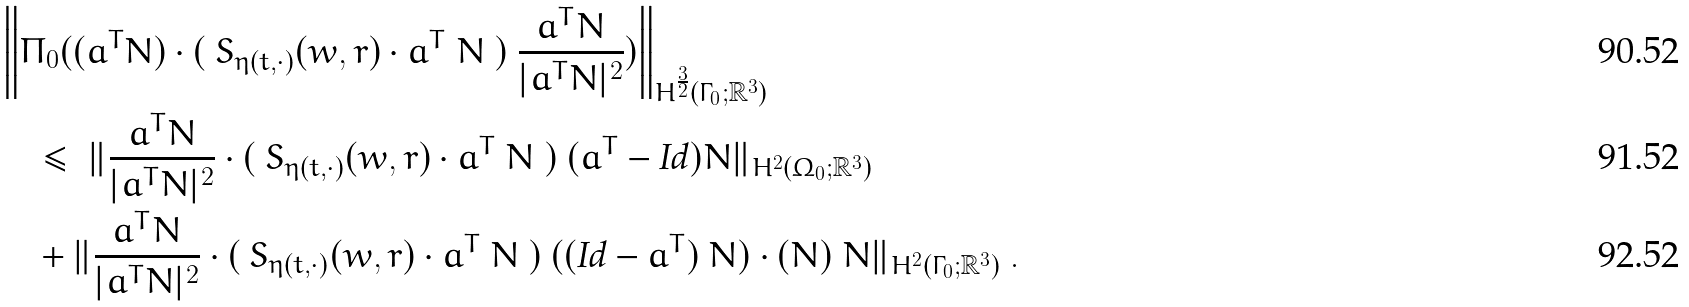Convert formula to latex. <formula><loc_0><loc_0><loc_500><loc_500>& \left \| \Pi _ { 0 } ( ( a ^ { T } N ) \cdot ( \ S _ { \eta ( t , \cdot ) } ( w , r ) \cdot a ^ { T } \ N \ ) \ \frac { a ^ { T } N } { | a ^ { T } N | ^ { 2 } } ) \right \| _ { H ^ { \frac { 3 } { 2 } } ( { \Gamma _ { 0 } } ; { \mathbb { R } } ^ { 3 } ) } \\ & \quad \leq \ \| \frac { a ^ { T } N } { | a ^ { T } N | ^ { 2 } } \cdot ( \ S _ { \eta ( t , \cdot ) } ( w , r ) \cdot a ^ { T } \ N \ ) \ ( a ^ { T } - \text {Id} ) N \| _ { H ^ { 2 } ( { \Omega _ { 0 } } ; { \mathbb { R } } ^ { 3 } ) } \\ & \quad + \| \frac { a ^ { T } N } { | a ^ { T } N | ^ { 2 } } \cdot ( \ S _ { \eta ( t , \cdot ) } ( w , r ) \cdot a ^ { T } \ N \ ) \ ( ( \text {Id} - a ^ { T } ) \ N ) \cdot ( N ) \ N \| _ { H ^ { 2 } ( { \Gamma _ { 0 } } ; { \mathbb { R } } ^ { 3 } ) } \ .</formula> 